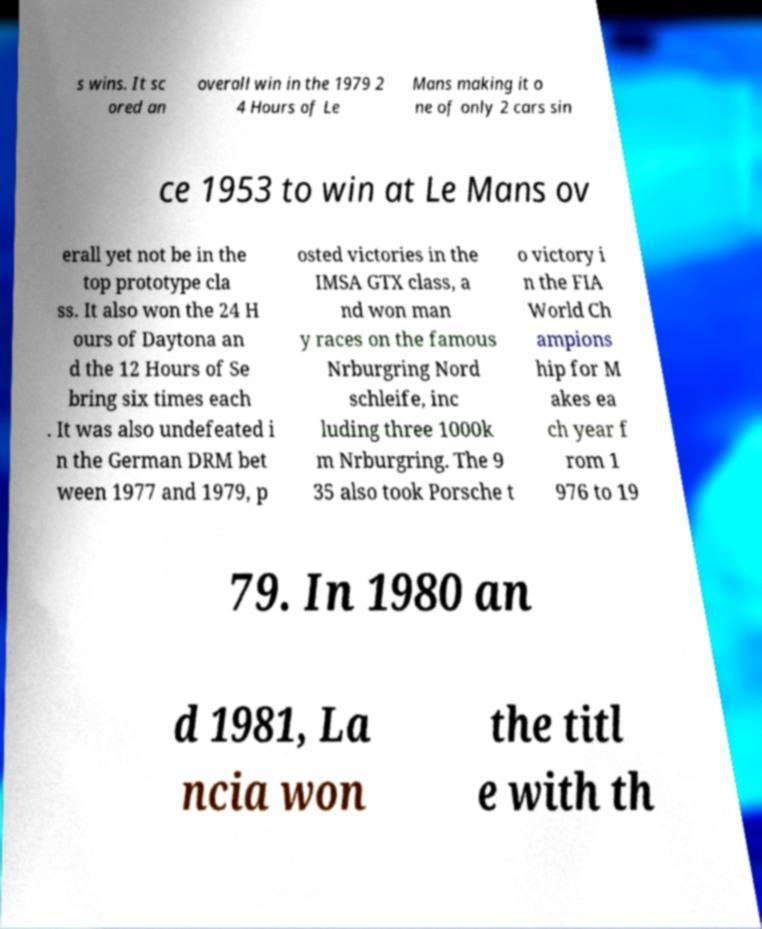I need the written content from this picture converted into text. Can you do that? s wins. It sc ored an overall win in the 1979 2 4 Hours of Le Mans making it o ne of only 2 cars sin ce 1953 to win at Le Mans ov erall yet not be in the top prototype cla ss. It also won the 24 H ours of Daytona an d the 12 Hours of Se bring six times each . It was also undefeated i n the German DRM bet ween 1977 and 1979, p osted victories in the IMSA GTX class, a nd won man y races on the famous Nrburgring Nord schleife, inc luding three 1000k m Nrburgring. The 9 35 also took Porsche t o victory i n the FIA World Ch ampions hip for M akes ea ch year f rom 1 976 to 19 79. In 1980 an d 1981, La ncia won the titl e with th 